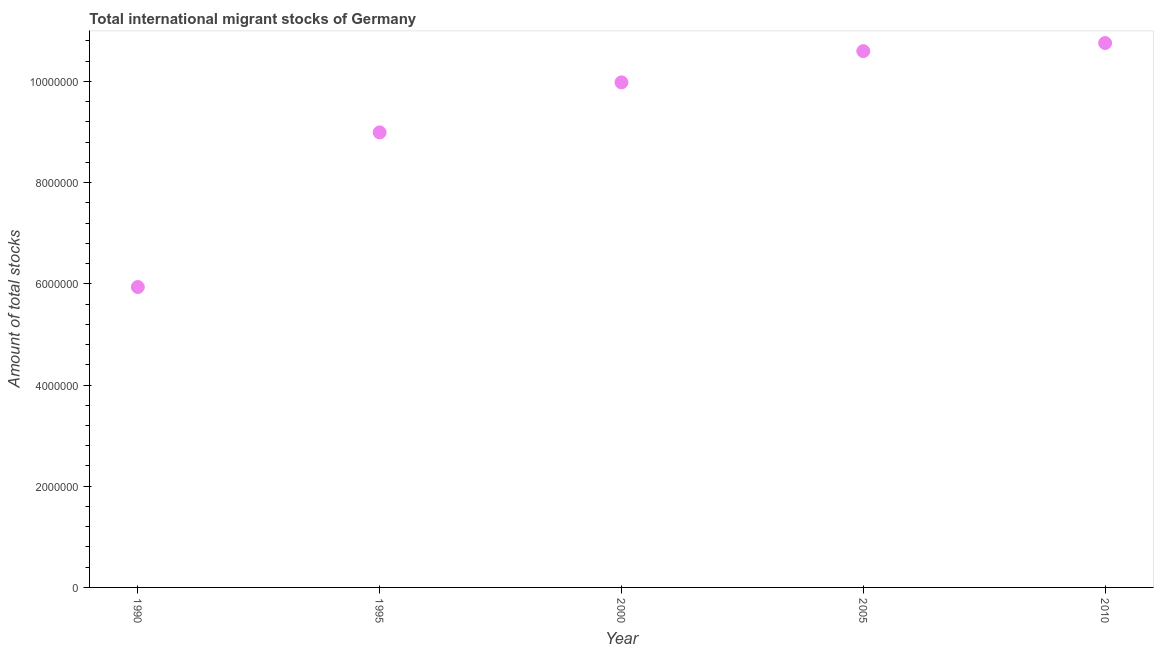What is the total number of international migrant stock in 1995?
Keep it short and to the point. 8.99e+06. Across all years, what is the maximum total number of international migrant stock?
Provide a succinct answer. 1.08e+07. Across all years, what is the minimum total number of international migrant stock?
Offer a terse response. 5.94e+06. In which year was the total number of international migrant stock maximum?
Your answer should be very brief. 2010. What is the sum of the total number of international migrant stock?
Your answer should be compact. 4.63e+07. What is the difference between the total number of international migrant stock in 1995 and 2005?
Offer a very short reply. -1.61e+06. What is the average total number of international migrant stock per year?
Provide a succinct answer. 9.25e+06. What is the median total number of international migrant stock?
Provide a short and direct response. 9.98e+06. What is the ratio of the total number of international migrant stock in 1990 to that in 1995?
Keep it short and to the point. 0.66. What is the difference between the highest and the second highest total number of international migrant stock?
Provide a succinct answer. 1.60e+05. What is the difference between the highest and the lowest total number of international migrant stock?
Make the answer very short. 4.82e+06. In how many years, is the total number of international migrant stock greater than the average total number of international migrant stock taken over all years?
Provide a short and direct response. 3. Does the total number of international migrant stock monotonically increase over the years?
Your answer should be very brief. Yes. How many dotlines are there?
Give a very brief answer. 1. What is the difference between two consecutive major ticks on the Y-axis?
Offer a terse response. 2.00e+06. Are the values on the major ticks of Y-axis written in scientific E-notation?
Provide a succinct answer. No. Does the graph contain any zero values?
Provide a short and direct response. No. Does the graph contain grids?
Provide a succinct answer. No. What is the title of the graph?
Your response must be concise. Total international migrant stocks of Germany. What is the label or title of the X-axis?
Your answer should be compact. Year. What is the label or title of the Y-axis?
Ensure brevity in your answer.  Amount of total stocks. What is the Amount of total stocks in 1990?
Your answer should be compact. 5.94e+06. What is the Amount of total stocks in 1995?
Your answer should be very brief. 8.99e+06. What is the Amount of total stocks in 2000?
Keep it short and to the point. 9.98e+06. What is the Amount of total stocks in 2005?
Your answer should be compact. 1.06e+07. What is the Amount of total stocks in 2010?
Your answer should be compact. 1.08e+07. What is the difference between the Amount of total stocks in 1990 and 1995?
Provide a short and direct response. -3.06e+06. What is the difference between the Amount of total stocks in 1990 and 2000?
Your answer should be compact. -4.04e+06. What is the difference between the Amount of total stocks in 1990 and 2005?
Your answer should be very brief. -4.66e+06. What is the difference between the Amount of total stocks in 1990 and 2010?
Give a very brief answer. -4.82e+06. What is the difference between the Amount of total stocks in 1995 and 2000?
Your response must be concise. -9.89e+05. What is the difference between the Amount of total stocks in 1995 and 2005?
Offer a terse response. -1.61e+06. What is the difference between the Amount of total stocks in 1995 and 2010?
Provide a succinct answer. -1.77e+06. What is the difference between the Amount of total stocks in 2000 and 2005?
Your answer should be very brief. -6.17e+05. What is the difference between the Amount of total stocks in 2000 and 2010?
Offer a terse response. -7.77e+05. What is the difference between the Amount of total stocks in 2005 and 2010?
Give a very brief answer. -1.60e+05. What is the ratio of the Amount of total stocks in 1990 to that in 1995?
Your answer should be very brief. 0.66. What is the ratio of the Amount of total stocks in 1990 to that in 2000?
Ensure brevity in your answer.  0.59. What is the ratio of the Amount of total stocks in 1990 to that in 2005?
Make the answer very short. 0.56. What is the ratio of the Amount of total stocks in 1990 to that in 2010?
Keep it short and to the point. 0.55. What is the ratio of the Amount of total stocks in 1995 to that in 2000?
Your response must be concise. 0.9. What is the ratio of the Amount of total stocks in 1995 to that in 2005?
Provide a succinct answer. 0.85. What is the ratio of the Amount of total stocks in 1995 to that in 2010?
Make the answer very short. 0.84. What is the ratio of the Amount of total stocks in 2000 to that in 2005?
Provide a short and direct response. 0.94. What is the ratio of the Amount of total stocks in 2000 to that in 2010?
Make the answer very short. 0.93. 